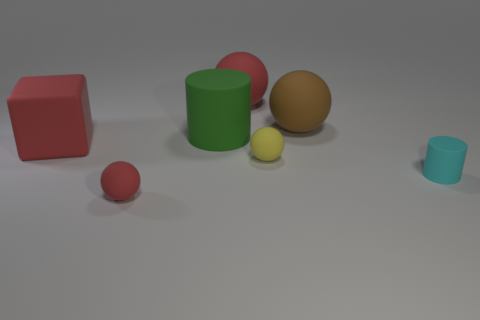There is a rubber sphere that is both in front of the large green rubber cylinder and right of the big red sphere; what color is it?
Keep it short and to the point. Yellow. Are there any small rubber spheres that have the same color as the tiny matte cylinder?
Provide a short and direct response. No. Are the cylinder that is left of the big brown object and the large red thing that is in front of the big red matte sphere made of the same material?
Make the answer very short. Yes. What is the size of the rubber ball that is in front of the cyan thing?
Provide a succinct answer. Small. How big is the red cube?
Your response must be concise. Large. What size is the rubber object that is left of the rubber ball left of the matte thing behind the brown object?
Provide a short and direct response. Large. Is there a large green cylinder that has the same material as the cube?
Provide a short and direct response. Yes. What shape is the big brown matte thing?
Provide a succinct answer. Sphere. There is a small cylinder that is made of the same material as the large cylinder; what color is it?
Make the answer very short. Cyan. How many gray things are either small matte objects or matte spheres?
Ensure brevity in your answer.  0. 